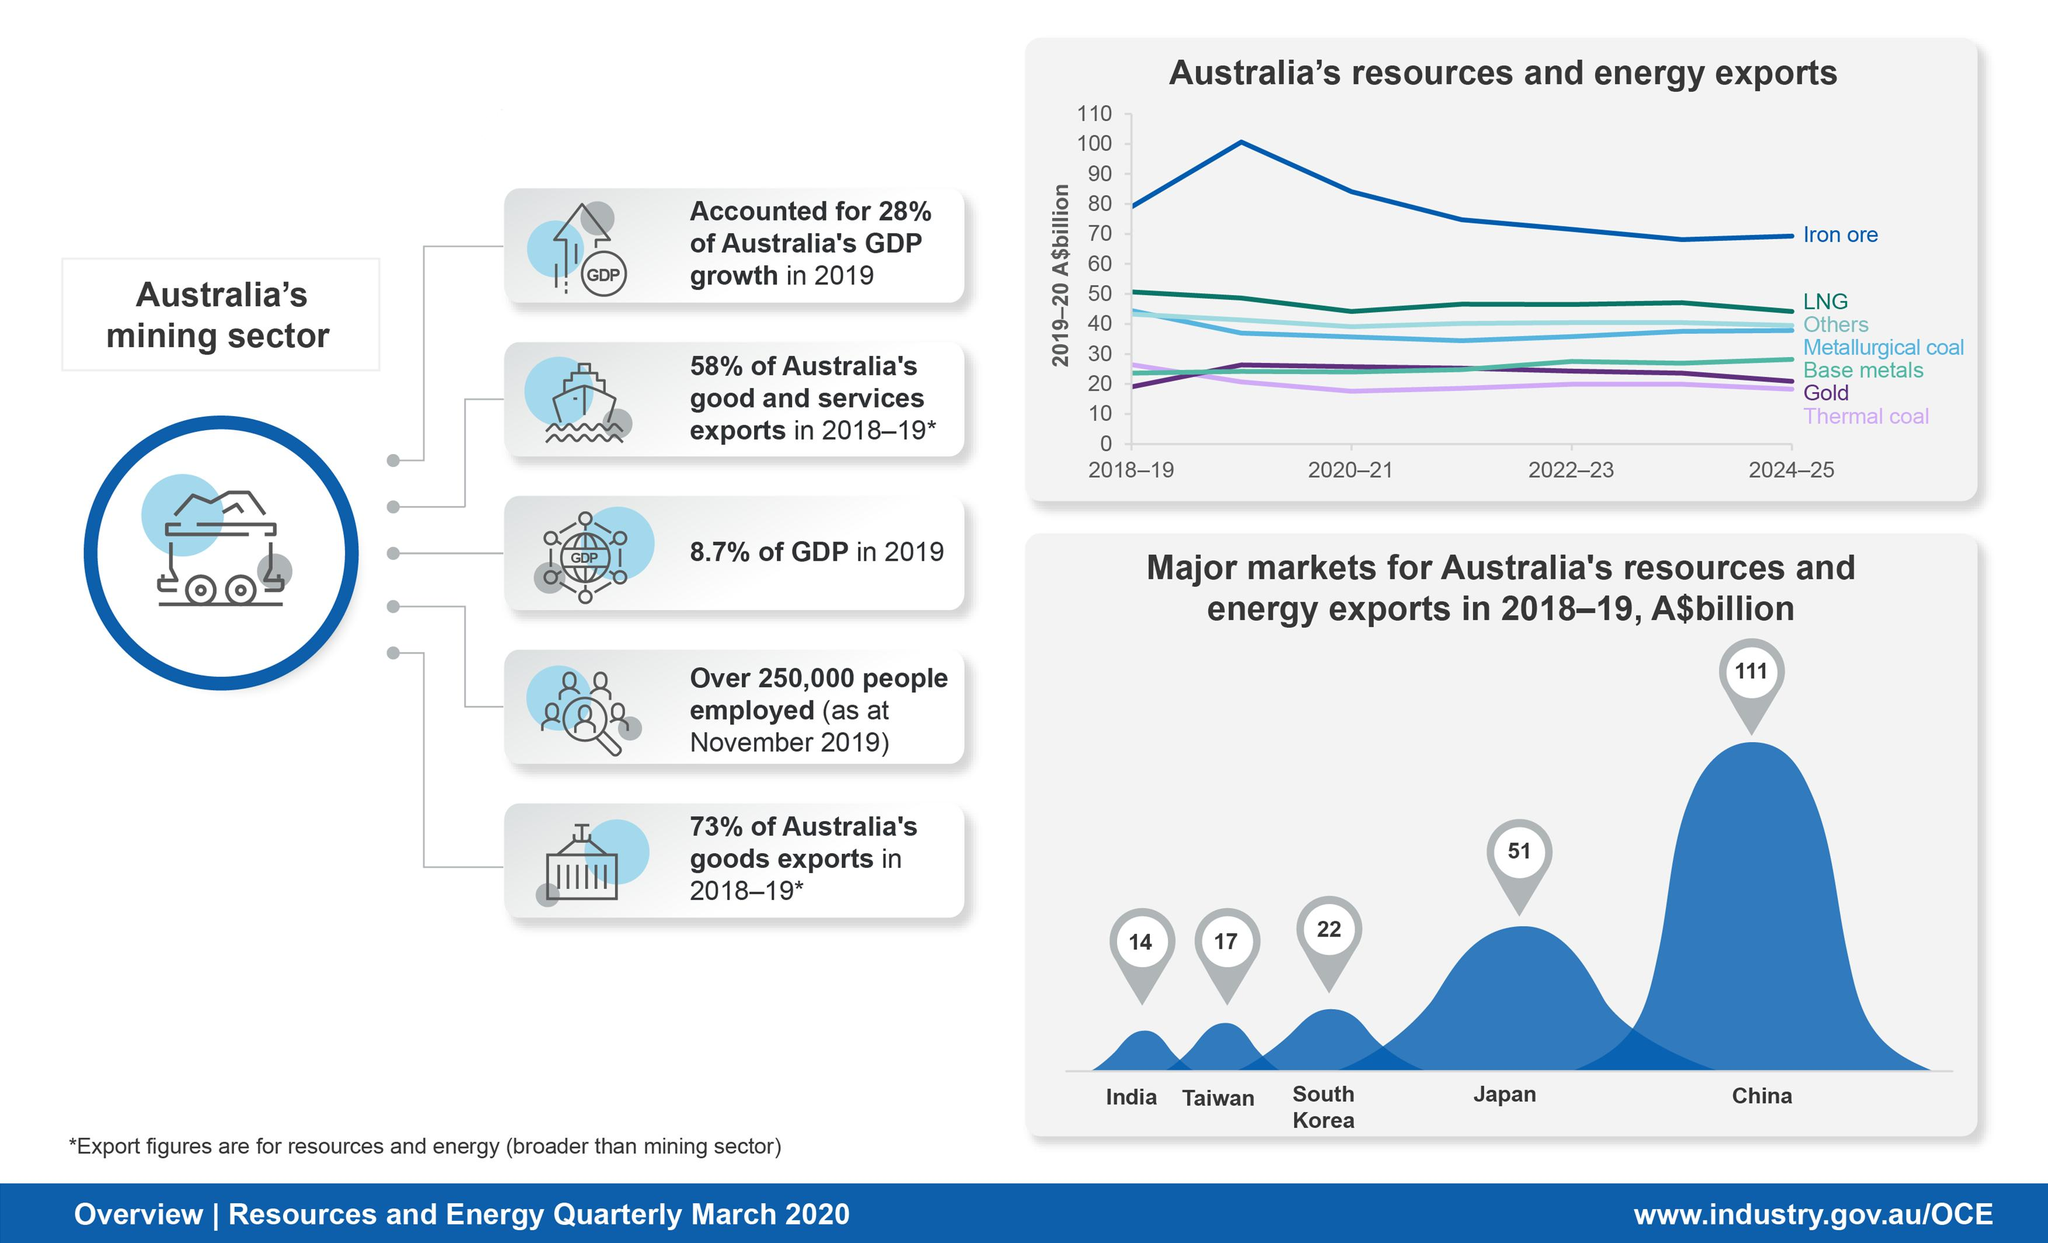Identify some key points in this picture. In 2019, the mining sector in Australia contributed 8.7% of the country's Gross Domestic Product (GDP), which is a significant percentage that highlights the importance of the mining industry to the country's economy. In 2018-2019, the mining sector accounted for 73% of Australia's total goods exports. Australia's resources and energy were heavily imported by China in 2018-2019, making it the top importer of these commodities from Australia. In 2018-19, the value of Australia's resources and energy exports to Taiwan was approximately 17 billion Australian dollars. Australia's resources and energy exports to Japan in 2018-19 were valued at approximately 51 billion Australian dollars. 